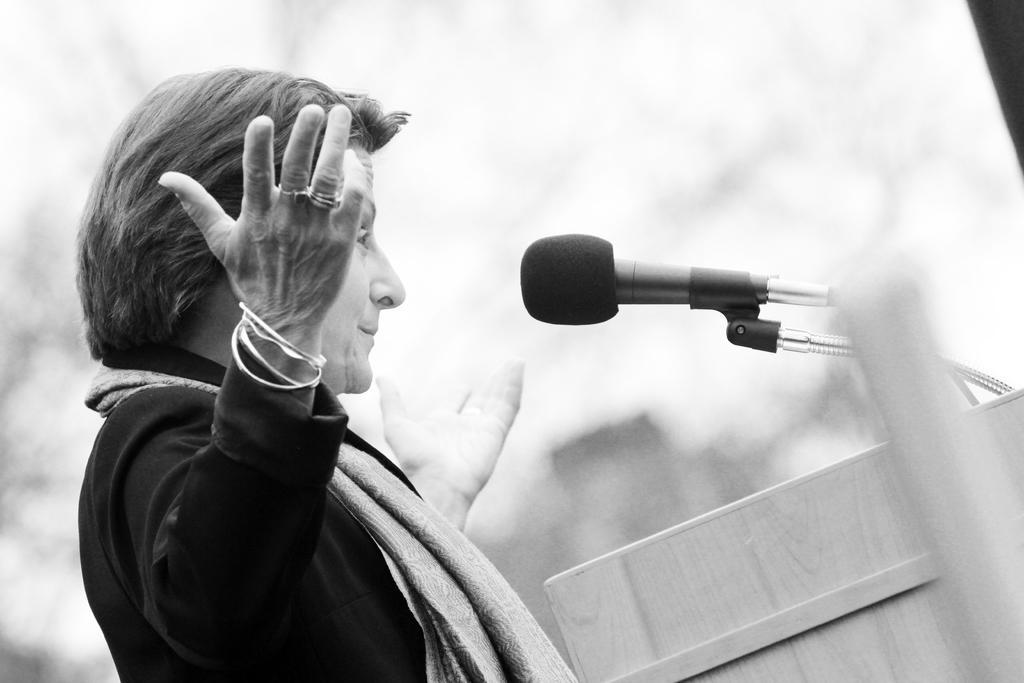Can you describe this image briefly? This image is taken outdoors. This image is a black and white image. On the right side of the image there is a podium with a mic. On the left side of the image there is a woman. She has worn a sweater and a scarf. 